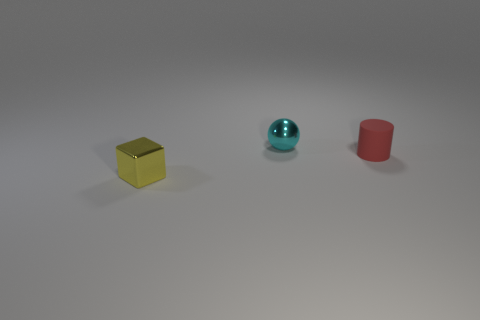Can you describe the shapes and colors of the objects in the image? Certainly! In the image, we have three distinctly shaped objects. On the left, there's a small cube with a shiny yellow surface. In the middle, there is a sphere with an aqua or light blue hue that has a reflective quality. And on the right, we see a cylinder that is colored red with a matte finish. 